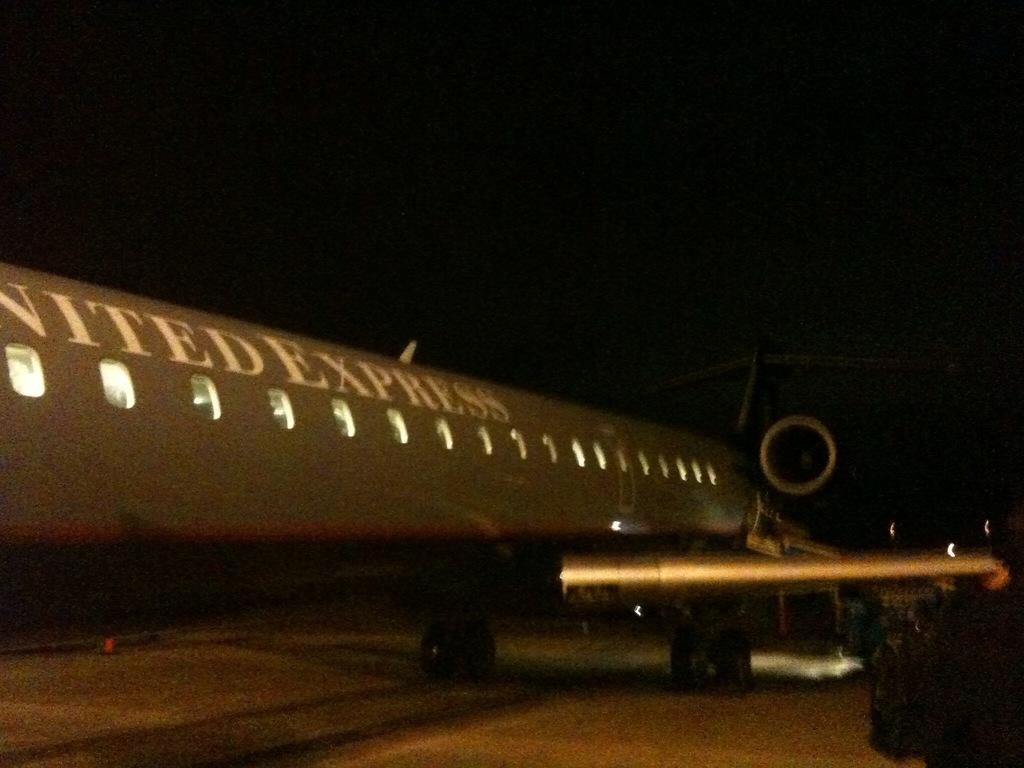What is the main subject of the image? The main subject of the image is an airplane. Where is the airplane located in the image? The airplane is on a runway. What can be observed about the background of the image? The background of the image is dark. What type of peace can be seen in the image? There is no reference to peace in the image; it features an airplane on a runway with a dark background. 